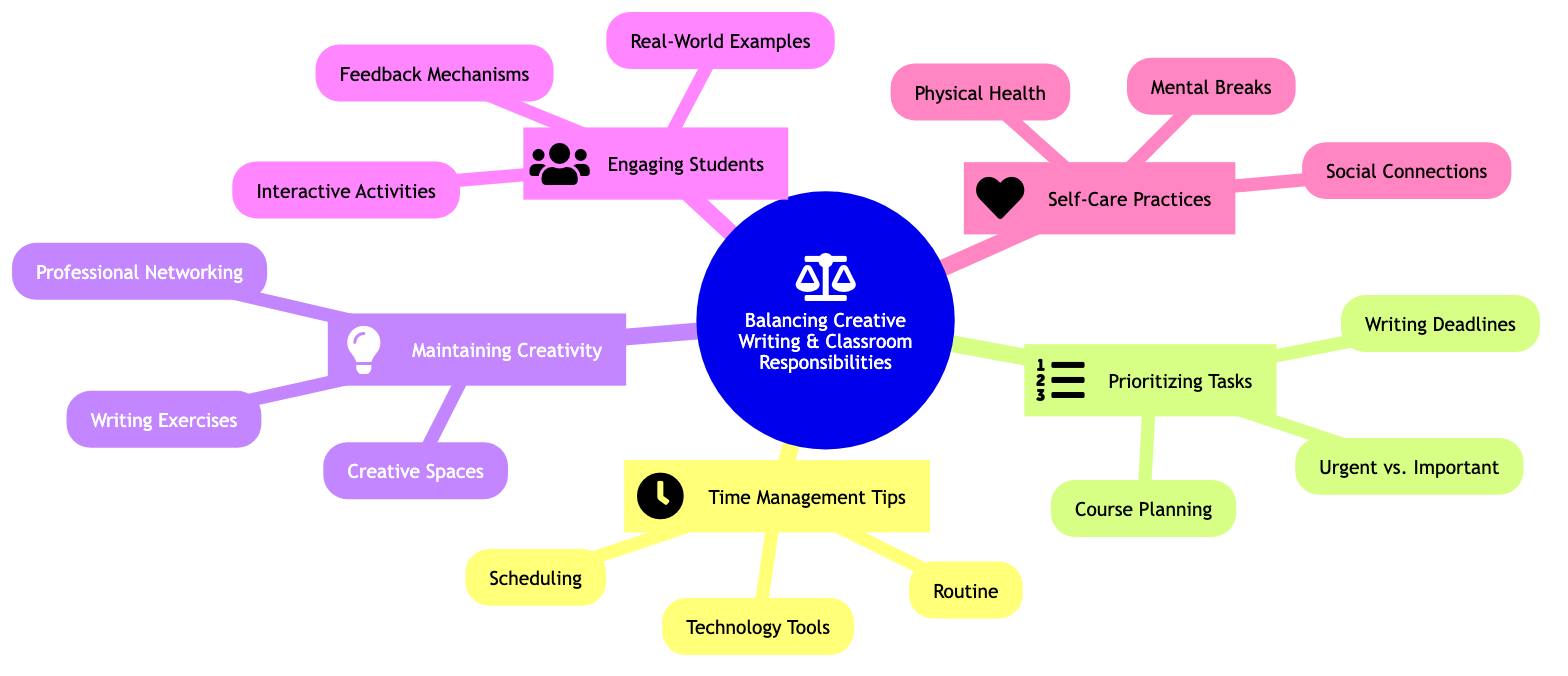What is the main topic of the mind map? The main topic is located at the root node, labeled "Balancing Creative Writing and Classroom Responsibilities."
Answer: Balancing Creative Writing and Classroom Responsibilities How many main branches are there in the mind map? The root node has five main branches extending from it: Time Management Tips, Prioritizing Tasks, Maintaining Creativity, Engaging Students, and Self-Care Practices. This means there are five main branches.
Answer: 5 What subtopic is associated with "Engaging Students"? The subtopic associated with "Engaging Students" includes three elements: Interactive Activities, Real-World Examples, and Feedback Mechanisms. The first one listed is "Interactive Activities."
Answer: Interactive Activities Which branch contains the concept of "Urgent vs. Important"? The "Urgent vs. Important" concept can be found under the "Prioritizing Tasks" branch, as it categorizes tasks based on their urgency and importance.
Answer: Prioritizing Tasks What techniques are suggested for self-care practices? Self-Care Practices includes Physical Health, Mental Breaks, and Social Connections, which encompass various techniques aimed at maintaining personal well-being.
Answer: Physical Health, Mental Breaks, Social Connections How does the mind map suggest maintaining creativity? To maintain creativity, the mind map suggests utilizing Creative Spaces, Writing Exercises, and Professional Networking, as these components collectively foster a creative environment.
Answer: Creative Spaces, Writing Exercises, Professional Networking What planning method is recommended for course preparation? The diagram indicates that course preparation is best approached by preparing class materials in advance, specifically during breaks or weekends.
Answer: Course Planning What is a key reason for participating in professional networking? The mind map suggests that joining screenwriting groups or attending workshops can help in exchanging ideas and remaining motivated, which indicates the importance of this activity for maintaining creative momentum.
Answer: Professional Networking 